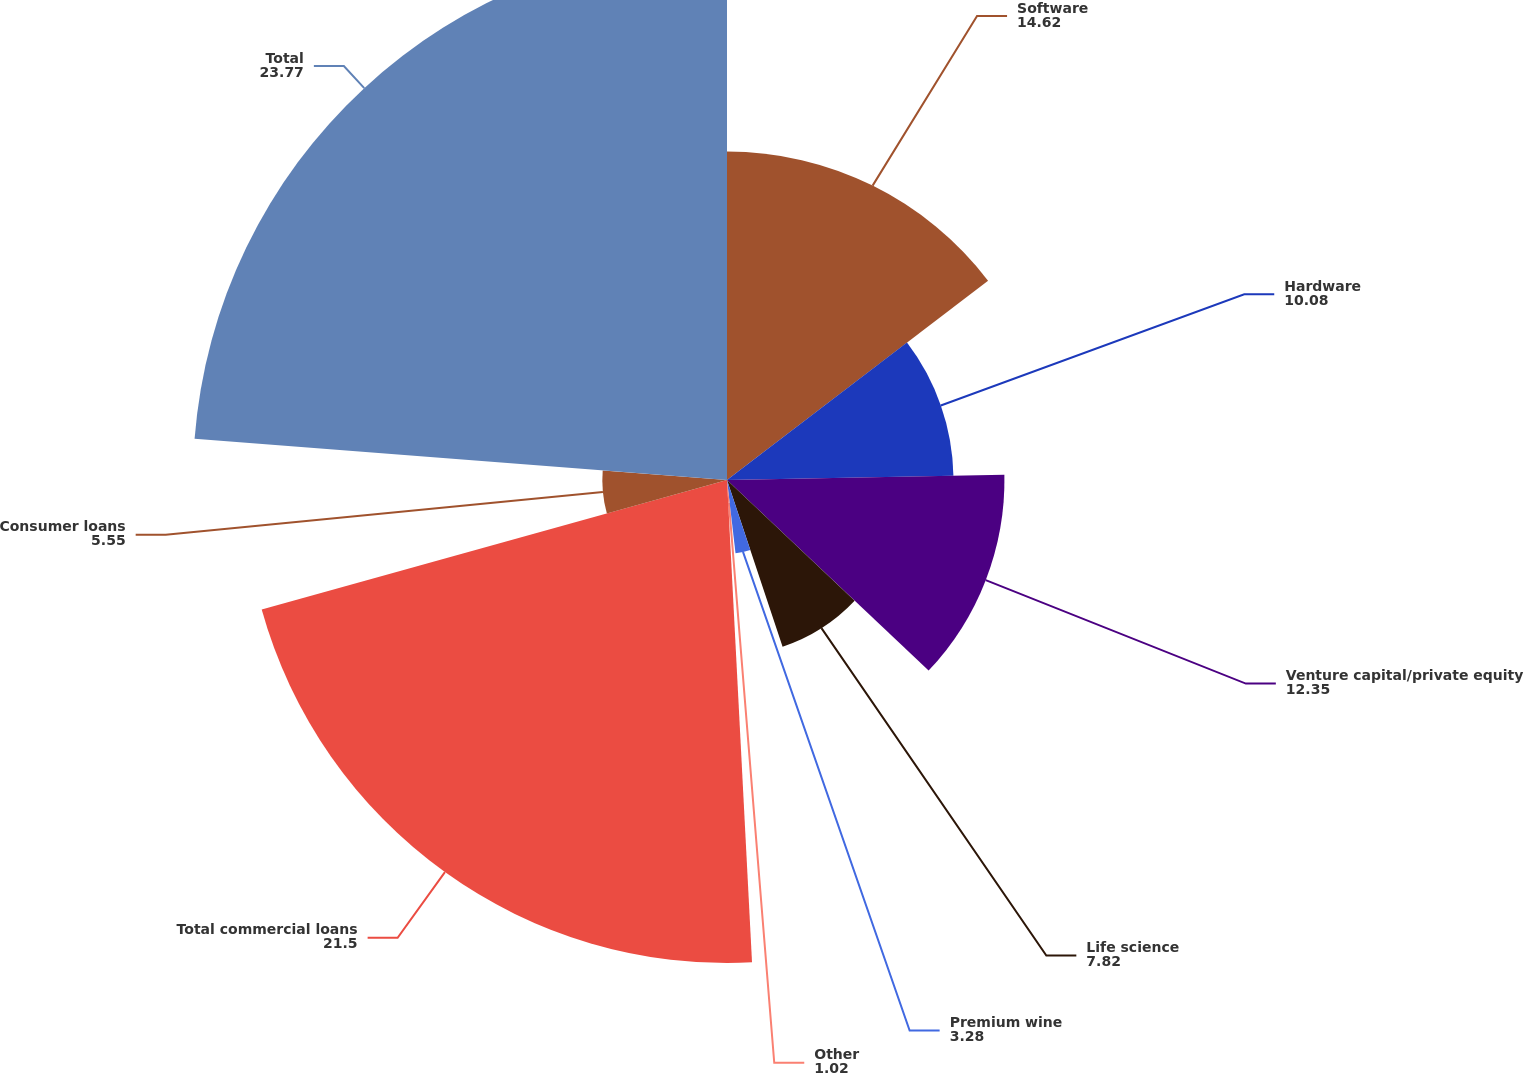Convert chart to OTSL. <chart><loc_0><loc_0><loc_500><loc_500><pie_chart><fcel>Software<fcel>Hardware<fcel>Venture capital/private equity<fcel>Life science<fcel>Premium wine<fcel>Other<fcel>Total commercial loans<fcel>Consumer loans<fcel>Total<nl><fcel>14.62%<fcel>10.08%<fcel>12.35%<fcel>7.82%<fcel>3.28%<fcel>1.02%<fcel>21.5%<fcel>5.55%<fcel>23.77%<nl></chart> 